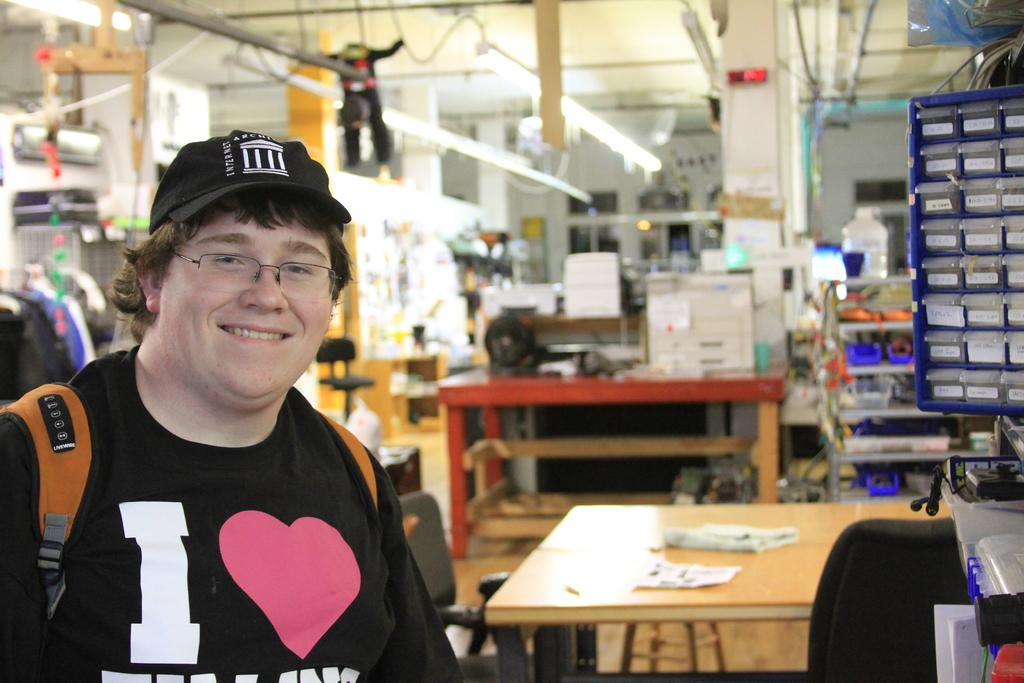What is the man in the image doing? The man is standing in the image and smiling. What is located near the man in the image? There is a table in the image. What is on the table in the image? There are papers on the table. Can you describe any other objects present in the image? There are some objects present in the image, but their specific details are not mentioned in the provided facts. What type of lettuce is being fed to the pig in the image? There is no pig or lettuce present in the image; it features a man standing near a table with papers on it. 